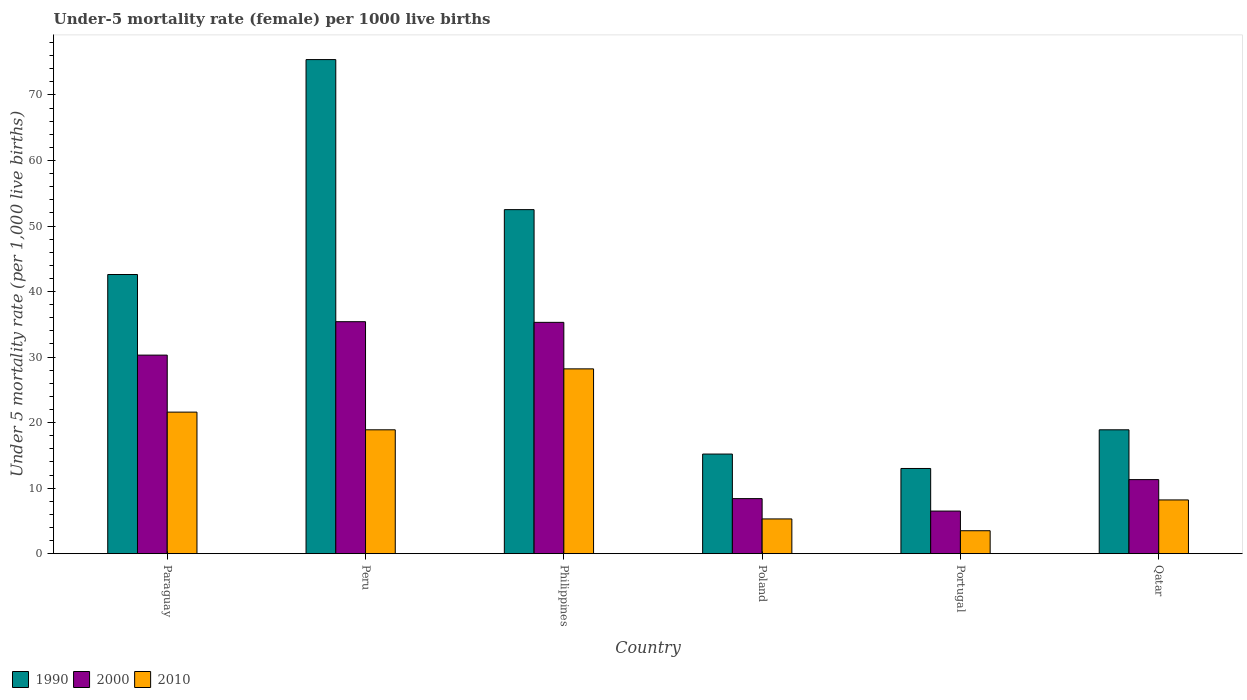How many bars are there on the 2nd tick from the left?
Your answer should be very brief. 3. How many bars are there on the 1st tick from the right?
Your response must be concise. 3. What is the label of the 4th group of bars from the left?
Provide a short and direct response. Poland. What is the under-five mortality rate in 2000 in Philippines?
Provide a short and direct response. 35.3. Across all countries, what is the maximum under-five mortality rate in 2000?
Your response must be concise. 35.4. Across all countries, what is the minimum under-five mortality rate in 2010?
Keep it short and to the point. 3.5. In which country was the under-five mortality rate in 2000 maximum?
Make the answer very short. Peru. In which country was the under-five mortality rate in 1990 minimum?
Provide a short and direct response. Portugal. What is the total under-five mortality rate in 2010 in the graph?
Make the answer very short. 85.7. What is the difference between the under-five mortality rate in 1990 in Philippines and that in Poland?
Provide a succinct answer. 37.3. What is the difference between the under-five mortality rate in 1990 in Peru and the under-five mortality rate in 2010 in Portugal?
Provide a short and direct response. 71.9. What is the average under-five mortality rate in 1990 per country?
Offer a very short reply. 36.27. What is the difference between the under-five mortality rate of/in 2000 and under-five mortality rate of/in 1990 in Poland?
Offer a very short reply. -6.8. What is the ratio of the under-five mortality rate in 2010 in Philippines to that in Qatar?
Offer a terse response. 3.44. Is the under-five mortality rate in 2000 in Peru less than that in Qatar?
Provide a short and direct response. No. Is the difference between the under-five mortality rate in 2000 in Philippines and Poland greater than the difference between the under-five mortality rate in 1990 in Philippines and Poland?
Make the answer very short. No. What is the difference between the highest and the second highest under-five mortality rate in 2010?
Keep it short and to the point. -9.3. What is the difference between the highest and the lowest under-five mortality rate in 2010?
Offer a terse response. 24.7. Is the sum of the under-five mortality rate in 2000 in Paraguay and Peru greater than the maximum under-five mortality rate in 2010 across all countries?
Your response must be concise. Yes. How many bars are there?
Keep it short and to the point. 18. How many countries are there in the graph?
Give a very brief answer. 6. Are the values on the major ticks of Y-axis written in scientific E-notation?
Give a very brief answer. No. Does the graph contain any zero values?
Ensure brevity in your answer.  No. Where does the legend appear in the graph?
Your answer should be very brief. Bottom left. What is the title of the graph?
Give a very brief answer. Under-5 mortality rate (female) per 1000 live births. Does "1983" appear as one of the legend labels in the graph?
Your response must be concise. No. What is the label or title of the Y-axis?
Give a very brief answer. Under 5 mortality rate (per 1,0 live births). What is the Under 5 mortality rate (per 1,000 live births) of 1990 in Paraguay?
Give a very brief answer. 42.6. What is the Under 5 mortality rate (per 1,000 live births) in 2000 in Paraguay?
Offer a terse response. 30.3. What is the Under 5 mortality rate (per 1,000 live births) in 2010 in Paraguay?
Keep it short and to the point. 21.6. What is the Under 5 mortality rate (per 1,000 live births) in 1990 in Peru?
Your response must be concise. 75.4. What is the Under 5 mortality rate (per 1,000 live births) in 2000 in Peru?
Keep it short and to the point. 35.4. What is the Under 5 mortality rate (per 1,000 live births) of 2010 in Peru?
Your answer should be very brief. 18.9. What is the Under 5 mortality rate (per 1,000 live births) in 1990 in Philippines?
Your answer should be very brief. 52.5. What is the Under 5 mortality rate (per 1,000 live births) of 2000 in Philippines?
Offer a very short reply. 35.3. What is the Under 5 mortality rate (per 1,000 live births) in 2010 in Philippines?
Your answer should be very brief. 28.2. What is the Under 5 mortality rate (per 1,000 live births) of 1990 in Portugal?
Keep it short and to the point. 13. What is the Under 5 mortality rate (per 1,000 live births) of 2000 in Portugal?
Your response must be concise. 6.5. Across all countries, what is the maximum Under 5 mortality rate (per 1,000 live births) in 1990?
Ensure brevity in your answer.  75.4. Across all countries, what is the maximum Under 5 mortality rate (per 1,000 live births) in 2000?
Offer a very short reply. 35.4. Across all countries, what is the maximum Under 5 mortality rate (per 1,000 live births) in 2010?
Provide a short and direct response. 28.2. Across all countries, what is the minimum Under 5 mortality rate (per 1,000 live births) of 1990?
Provide a succinct answer. 13. What is the total Under 5 mortality rate (per 1,000 live births) of 1990 in the graph?
Your response must be concise. 217.6. What is the total Under 5 mortality rate (per 1,000 live births) in 2000 in the graph?
Keep it short and to the point. 127.2. What is the total Under 5 mortality rate (per 1,000 live births) of 2010 in the graph?
Provide a succinct answer. 85.7. What is the difference between the Under 5 mortality rate (per 1,000 live births) in 1990 in Paraguay and that in Peru?
Make the answer very short. -32.8. What is the difference between the Under 5 mortality rate (per 1,000 live births) in 2000 in Paraguay and that in Peru?
Your response must be concise. -5.1. What is the difference between the Under 5 mortality rate (per 1,000 live births) in 1990 in Paraguay and that in Poland?
Provide a short and direct response. 27.4. What is the difference between the Under 5 mortality rate (per 1,000 live births) of 2000 in Paraguay and that in Poland?
Provide a short and direct response. 21.9. What is the difference between the Under 5 mortality rate (per 1,000 live births) in 2010 in Paraguay and that in Poland?
Keep it short and to the point. 16.3. What is the difference between the Under 5 mortality rate (per 1,000 live births) of 1990 in Paraguay and that in Portugal?
Ensure brevity in your answer.  29.6. What is the difference between the Under 5 mortality rate (per 1,000 live births) of 2000 in Paraguay and that in Portugal?
Your response must be concise. 23.8. What is the difference between the Under 5 mortality rate (per 1,000 live births) in 1990 in Paraguay and that in Qatar?
Keep it short and to the point. 23.7. What is the difference between the Under 5 mortality rate (per 1,000 live births) in 1990 in Peru and that in Philippines?
Your response must be concise. 22.9. What is the difference between the Under 5 mortality rate (per 1,000 live births) in 2010 in Peru and that in Philippines?
Ensure brevity in your answer.  -9.3. What is the difference between the Under 5 mortality rate (per 1,000 live births) in 1990 in Peru and that in Poland?
Your answer should be very brief. 60.2. What is the difference between the Under 5 mortality rate (per 1,000 live births) of 2000 in Peru and that in Poland?
Provide a short and direct response. 27. What is the difference between the Under 5 mortality rate (per 1,000 live births) of 2010 in Peru and that in Poland?
Offer a terse response. 13.6. What is the difference between the Under 5 mortality rate (per 1,000 live births) of 1990 in Peru and that in Portugal?
Your response must be concise. 62.4. What is the difference between the Under 5 mortality rate (per 1,000 live births) in 2000 in Peru and that in Portugal?
Make the answer very short. 28.9. What is the difference between the Under 5 mortality rate (per 1,000 live births) of 2010 in Peru and that in Portugal?
Your answer should be very brief. 15.4. What is the difference between the Under 5 mortality rate (per 1,000 live births) of 1990 in Peru and that in Qatar?
Make the answer very short. 56.5. What is the difference between the Under 5 mortality rate (per 1,000 live births) of 2000 in Peru and that in Qatar?
Your answer should be compact. 24.1. What is the difference between the Under 5 mortality rate (per 1,000 live births) in 2010 in Peru and that in Qatar?
Ensure brevity in your answer.  10.7. What is the difference between the Under 5 mortality rate (per 1,000 live births) of 1990 in Philippines and that in Poland?
Ensure brevity in your answer.  37.3. What is the difference between the Under 5 mortality rate (per 1,000 live births) in 2000 in Philippines and that in Poland?
Keep it short and to the point. 26.9. What is the difference between the Under 5 mortality rate (per 1,000 live births) of 2010 in Philippines and that in Poland?
Offer a very short reply. 22.9. What is the difference between the Under 5 mortality rate (per 1,000 live births) of 1990 in Philippines and that in Portugal?
Offer a very short reply. 39.5. What is the difference between the Under 5 mortality rate (per 1,000 live births) of 2000 in Philippines and that in Portugal?
Offer a terse response. 28.8. What is the difference between the Under 5 mortality rate (per 1,000 live births) in 2010 in Philippines and that in Portugal?
Provide a succinct answer. 24.7. What is the difference between the Under 5 mortality rate (per 1,000 live births) of 1990 in Philippines and that in Qatar?
Provide a succinct answer. 33.6. What is the difference between the Under 5 mortality rate (per 1,000 live births) in 2000 in Philippines and that in Qatar?
Your response must be concise. 24. What is the difference between the Under 5 mortality rate (per 1,000 live births) in 2010 in Philippines and that in Qatar?
Provide a short and direct response. 20. What is the difference between the Under 5 mortality rate (per 1,000 live births) in 1990 in Poland and that in Portugal?
Provide a short and direct response. 2.2. What is the difference between the Under 5 mortality rate (per 1,000 live births) of 2000 in Poland and that in Qatar?
Offer a very short reply. -2.9. What is the difference between the Under 5 mortality rate (per 1,000 live births) of 1990 in Portugal and that in Qatar?
Offer a terse response. -5.9. What is the difference between the Under 5 mortality rate (per 1,000 live births) of 2010 in Portugal and that in Qatar?
Offer a very short reply. -4.7. What is the difference between the Under 5 mortality rate (per 1,000 live births) of 1990 in Paraguay and the Under 5 mortality rate (per 1,000 live births) of 2000 in Peru?
Ensure brevity in your answer.  7.2. What is the difference between the Under 5 mortality rate (per 1,000 live births) of 1990 in Paraguay and the Under 5 mortality rate (per 1,000 live births) of 2010 in Peru?
Your answer should be very brief. 23.7. What is the difference between the Under 5 mortality rate (per 1,000 live births) in 1990 in Paraguay and the Under 5 mortality rate (per 1,000 live births) in 2000 in Philippines?
Give a very brief answer. 7.3. What is the difference between the Under 5 mortality rate (per 1,000 live births) of 1990 in Paraguay and the Under 5 mortality rate (per 1,000 live births) of 2010 in Philippines?
Offer a very short reply. 14.4. What is the difference between the Under 5 mortality rate (per 1,000 live births) in 1990 in Paraguay and the Under 5 mortality rate (per 1,000 live births) in 2000 in Poland?
Offer a terse response. 34.2. What is the difference between the Under 5 mortality rate (per 1,000 live births) of 1990 in Paraguay and the Under 5 mortality rate (per 1,000 live births) of 2010 in Poland?
Keep it short and to the point. 37.3. What is the difference between the Under 5 mortality rate (per 1,000 live births) in 1990 in Paraguay and the Under 5 mortality rate (per 1,000 live births) in 2000 in Portugal?
Provide a succinct answer. 36.1. What is the difference between the Under 5 mortality rate (per 1,000 live births) in 1990 in Paraguay and the Under 5 mortality rate (per 1,000 live births) in 2010 in Portugal?
Your answer should be compact. 39.1. What is the difference between the Under 5 mortality rate (per 1,000 live births) of 2000 in Paraguay and the Under 5 mortality rate (per 1,000 live births) of 2010 in Portugal?
Your response must be concise. 26.8. What is the difference between the Under 5 mortality rate (per 1,000 live births) in 1990 in Paraguay and the Under 5 mortality rate (per 1,000 live births) in 2000 in Qatar?
Provide a short and direct response. 31.3. What is the difference between the Under 5 mortality rate (per 1,000 live births) in 1990 in Paraguay and the Under 5 mortality rate (per 1,000 live births) in 2010 in Qatar?
Keep it short and to the point. 34.4. What is the difference between the Under 5 mortality rate (per 1,000 live births) in 2000 in Paraguay and the Under 5 mortality rate (per 1,000 live births) in 2010 in Qatar?
Offer a very short reply. 22.1. What is the difference between the Under 5 mortality rate (per 1,000 live births) in 1990 in Peru and the Under 5 mortality rate (per 1,000 live births) in 2000 in Philippines?
Make the answer very short. 40.1. What is the difference between the Under 5 mortality rate (per 1,000 live births) in 1990 in Peru and the Under 5 mortality rate (per 1,000 live births) in 2010 in Philippines?
Ensure brevity in your answer.  47.2. What is the difference between the Under 5 mortality rate (per 1,000 live births) of 1990 in Peru and the Under 5 mortality rate (per 1,000 live births) of 2010 in Poland?
Your answer should be compact. 70.1. What is the difference between the Under 5 mortality rate (per 1,000 live births) of 2000 in Peru and the Under 5 mortality rate (per 1,000 live births) of 2010 in Poland?
Provide a short and direct response. 30.1. What is the difference between the Under 5 mortality rate (per 1,000 live births) of 1990 in Peru and the Under 5 mortality rate (per 1,000 live births) of 2000 in Portugal?
Give a very brief answer. 68.9. What is the difference between the Under 5 mortality rate (per 1,000 live births) of 1990 in Peru and the Under 5 mortality rate (per 1,000 live births) of 2010 in Portugal?
Your answer should be very brief. 71.9. What is the difference between the Under 5 mortality rate (per 1,000 live births) in 2000 in Peru and the Under 5 mortality rate (per 1,000 live births) in 2010 in Portugal?
Your response must be concise. 31.9. What is the difference between the Under 5 mortality rate (per 1,000 live births) in 1990 in Peru and the Under 5 mortality rate (per 1,000 live births) in 2000 in Qatar?
Offer a terse response. 64.1. What is the difference between the Under 5 mortality rate (per 1,000 live births) of 1990 in Peru and the Under 5 mortality rate (per 1,000 live births) of 2010 in Qatar?
Your answer should be compact. 67.2. What is the difference between the Under 5 mortality rate (per 1,000 live births) of 2000 in Peru and the Under 5 mortality rate (per 1,000 live births) of 2010 in Qatar?
Your answer should be compact. 27.2. What is the difference between the Under 5 mortality rate (per 1,000 live births) in 1990 in Philippines and the Under 5 mortality rate (per 1,000 live births) in 2000 in Poland?
Make the answer very short. 44.1. What is the difference between the Under 5 mortality rate (per 1,000 live births) of 1990 in Philippines and the Under 5 mortality rate (per 1,000 live births) of 2010 in Poland?
Keep it short and to the point. 47.2. What is the difference between the Under 5 mortality rate (per 1,000 live births) of 1990 in Philippines and the Under 5 mortality rate (per 1,000 live births) of 2000 in Portugal?
Give a very brief answer. 46. What is the difference between the Under 5 mortality rate (per 1,000 live births) in 2000 in Philippines and the Under 5 mortality rate (per 1,000 live births) in 2010 in Portugal?
Ensure brevity in your answer.  31.8. What is the difference between the Under 5 mortality rate (per 1,000 live births) in 1990 in Philippines and the Under 5 mortality rate (per 1,000 live births) in 2000 in Qatar?
Give a very brief answer. 41.2. What is the difference between the Under 5 mortality rate (per 1,000 live births) of 1990 in Philippines and the Under 5 mortality rate (per 1,000 live births) of 2010 in Qatar?
Give a very brief answer. 44.3. What is the difference between the Under 5 mortality rate (per 1,000 live births) in 2000 in Philippines and the Under 5 mortality rate (per 1,000 live births) in 2010 in Qatar?
Your answer should be compact. 27.1. What is the difference between the Under 5 mortality rate (per 1,000 live births) of 2000 in Poland and the Under 5 mortality rate (per 1,000 live births) of 2010 in Portugal?
Make the answer very short. 4.9. What is the difference between the Under 5 mortality rate (per 1,000 live births) of 1990 in Poland and the Under 5 mortality rate (per 1,000 live births) of 2000 in Qatar?
Give a very brief answer. 3.9. What is the difference between the Under 5 mortality rate (per 1,000 live births) in 1990 in Poland and the Under 5 mortality rate (per 1,000 live births) in 2010 in Qatar?
Ensure brevity in your answer.  7. What is the difference between the Under 5 mortality rate (per 1,000 live births) of 1990 in Portugal and the Under 5 mortality rate (per 1,000 live births) of 2000 in Qatar?
Offer a terse response. 1.7. What is the average Under 5 mortality rate (per 1,000 live births) in 1990 per country?
Keep it short and to the point. 36.27. What is the average Under 5 mortality rate (per 1,000 live births) in 2000 per country?
Your response must be concise. 21.2. What is the average Under 5 mortality rate (per 1,000 live births) in 2010 per country?
Keep it short and to the point. 14.28. What is the difference between the Under 5 mortality rate (per 1,000 live births) in 1990 and Under 5 mortality rate (per 1,000 live births) in 2000 in Paraguay?
Offer a very short reply. 12.3. What is the difference between the Under 5 mortality rate (per 1,000 live births) of 2000 and Under 5 mortality rate (per 1,000 live births) of 2010 in Paraguay?
Make the answer very short. 8.7. What is the difference between the Under 5 mortality rate (per 1,000 live births) in 1990 and Under 5 mortality rate (per 1,000 live births) in 2000 in Peru?
Give a very brief answer. 40. What is the difference between the Under 5 mortality rate (per 1,000 live births) in 1990 and Under 5 mortality rate (per 1,000 live births) in 2010 in Peru?
Make the answer very short. 56.5. What is the difference between the Under 5 mortality rate (per 1,000 live births) in 1990 and Under 5 mortality rate (per 1,000 live births) in 2010 in Philippines?
Make the answer very short. 24.3. What is the difference between the Under 5 mortality rate (per 1,000 live births) of 2000 and Under 5 mortality rate (per 1,000 live births) of 2010 in Philippines?
Ensure brevity in your answer.  7.1. What is the difference between the Under 5 mortality rate (per 1,000 live births) in 1990 and Under 5 mortality rate (per 1,000 live births) in 2000 in Qatar?
Offer a very short reply. 7.6. What is the difference between the Under 5 mortality rate (per 1,000 live births) in 2000 and Under 5 mortality rate (per 1,000 live births) in 2010 in Qatar?
Your answer should be compact. 3.1. What is the ratio of the Under 5 mortality rate (per 1,000 live births) in 1990 in Paraguay to that in Peru?
Provide a succinct answer. 0.56. What is the ratio of the Under 5 mortality rate (per 1,000 live births) in 2000 in Paraguay to that in Peru?
Provide a short and direct response. 0.86. What is the ratio of the Under 5 mortality rate (per 1,000 live births) in 1990 in Paraguay to that in Philippines?
Your response must be concise. 0.81. What is the ratio of the Under 5 mortality rate (per 1,000 live births) in 2000 in Paraguay to that in Philippines?
Offer a terse response. 0.86. What is the ratio of the Under 5 mortality rate (per 1,000 live births) in 2010 in Paraguay to that in Philippines?
Give a very brief answer. 0.77. What is the ratio of the Under 5 mortality rate (per 1,000 live births) in 1990 in Paraguay to that in Poland?
Offer a very short reply. 2.8. What is the ratio of the Under 5 mortality rate (per 1,000 live births) of 2000 in Paraguay to that in Poland?
Your answer should be compact. 3.61. What is the ratio of the Under 5 mortality rate (per 1,000 live births) of 2010 in Paraguay to that in Poland?
Make the answer very short. 4.08. What is the ratio of the Under 5 mortality rate (per 1,000 live births) in 1990 in Paraguay to that in Portugal?
Give a very brief answer. 3.28. What is the ratio of the Under 5 mortality rate (per 1,000 live births) in 2000 in Paraguay to that in Portugal?
Give a very brief answer. 4.66. What is the ratio of the Under 5 mortality rate (per 1,000 live births) in 2010 in Paraguay to that in Portugal?
Your answer should be very brief. 6.17. What is the ratio of the Under 5 mortality rate (per 1,000 live births) in 1990 in Paraguay to that in Qatar?
Your answer should be compact. 2.25. What is the ratio of the Under 5 mortality rate (per 1,000 live births) in 2000 in Paraguay to that in Qatar?
Offer a very short reply. 2.68. What is the ratio of the Under 5 mortality rate (per 1,000 live births) of 2010 in Paraguay to that in Qatar?
Your response must be concise. 2.63. What is the ratio of the Under 5 mortality rate (per 1,000 live births) of 1990 in Peru to that in Philippines?
Ensure brevity in your answer.  1.44. What is the ratio of the Under 5 mortality rate (per 1,000 live births) in 2000 in Peru to that in Philippines?
Provide a succinct answer. 1. What is the ratio of the Under 5 mortality rate (per 1,000 live births) in 2010 in Peru to that in Philippines?
Offer a very short reply. 0.67. What is the ratio of the Under 5 mortality rate (per 1,000 live births) of 1990 in Peru to that in Poland?
Keep it short and to the point. 4.96. What is the ratio of the Under 5 mortality rate (per 1,000 live births) in 2000 in Peru to that in Poland?
Provide a succinct answer. 4.21. What is the ratio of the Under 5 mortality rate (per 1,000 live births) of 2010 in Peru to that in Poland?
Your response must be concise. 3.57. What is the ratio of the Under 5 mortality rate (per 1,000 live births) of 1990 in Peru to that in Portugal?
Provide a succinct answer. 5.8. What is the ratio of the Under 5 mortality rate (per 1,000 live births) of 2000 in Peru to that in Portugal?
Provide a short and direct response. 5.45. What is the ratio of the Under 5 mortality rate (per 1,000 live births) in 2010 in Peru to that in Portugal?
Your response must be concise. 5.4. What is the ratio of the Under 5 mortality rate (per 1,000 live births) in 1990 in Peru to that in Qatar?
Make the answer very short. 3.99. What is the ratio of the Under 5 mortality rate (per 1,000 live births) of 2000 in Peru to that in Qatar?
Offer a very short reply. 3.13. What is the ratio of the Under 5 mortality rate (per 1,000 live births) in 2010 in Peru to that in Qatar?
Offer a very short reply. 2.3. What is the ratio of the Under 5 mortality rate (per 1,000 live births) in 1990 in Philippines to that in Poland?
Provide a short and direct response. 3.45. What is the ratio of the Under 5 mortality rate (per 1,000 live births) in 2000 in Philippines to that in Poland?
Provide a succinct answer. 4.2. What is the ratio of the Under 5 mortality rate (per 1,000 live births) of 2010 in Philippines to that in Poland?
Offer a very short reply. 5.32. What is the ratio of the Under 5 mortality rate (per 1,000 live births) in 1990 in Philippines to that in Portugal?
Your answer should be very brief. 4.04. What is the ratio of the Under 5 mortality rate (per 1,000 live births) in 2000 in Philippines to that in Portugal?
Your answer should be very brief. 5.43. What is the ratio of the Under 5 mortality rate (per 1,000 live births) in 2010 in Philippines to that in Portugal?
Your answer should be very brief. 8.06. What is the ratio of the Under 5 mortality rate (per 1,000 live births) in 1990 in Philippines to that in Qatar?
Make the answer very short. 2.78. What is the ratio of the Under 5 mortality rate (per 1,000 live births) in 2000 in Philippines to that in Qatar?
Offer a terse response. 3.12. What is the ratio of the Under 5 mortality rate (per 1,000 live births) of 2010 in Philippines to that in Qatar?
Offer a very short reply. 3.44. What is the ratio of the Under 5 mortality rate (per 1,000 live births) in 1990 in Poland to that in Portugal?
Your answer should be compact. 1.17. What is the ratio of the Under 5 mortality rate (per 1,000 live births) in 2000 in Poland to that in Portugal?
Your response must be concise. 1.29. What is the ratio of the Under 5 mortality rate (per 1,000 live births) of 2010 in Poland to that in Portugal?
Your response must be concise. 1.51. What is the ratio of the Under 5 mortality rate (per 1,000 live births) of 1990 in Poland to that in Qatar?
Give a very brief answer. 0.8. What is the ratio of the Under 5 mortality rate (per 1,000 live births) of 2000 in Poland to that in Qatar?
Provide a succinct answer. 0.74. What is the ratio of the Under 5 mortality rate (per 1,000 live births) of 2010 in Poland to that in Qatar?
Keep it short and to the point. 0.65. What is the ratio of the Under 5 mortality rate (per 1,000 live births) of 1990 in Portugal to that in Qatar?
Offer a terse response. 0.69. What is the ratio of the Under 5 mortality rate (per 1,000 live births) of 2000 in Portugal to that in Qatar?
Provide a succinct answer. 0.58. What is the ratio of the Under 5 mortality rate (per 1,000 live births) of 2010 in Portugal to that in Qatar?
Your response must be concise. 0.43. What is the difference between the highest and the second highest Under 5 mortality rate (per 1,000 live births) in 1990?
Your answer should be compact. 22.9. What is the difference between the highest and the second highest Under 5 mortality rate (per 1,000 live births) of 2000?
Provide a succinct answer. 0.1. What is the difference between the highest and the lowest Under 5 mortality rate (per 1,000 live births) of 1990?
Keep it short and to the point. 62.4. What is the difference between the highest and the lowest Under 5 mortality rate (per 1,000 live births) in 2000?
Offer a very short reply. 28.9. What is the difference between the highest and the lowest Under 5 mortality rate (per 1,000 live births) in 2010?
Offer a very short reply. 24.7. 